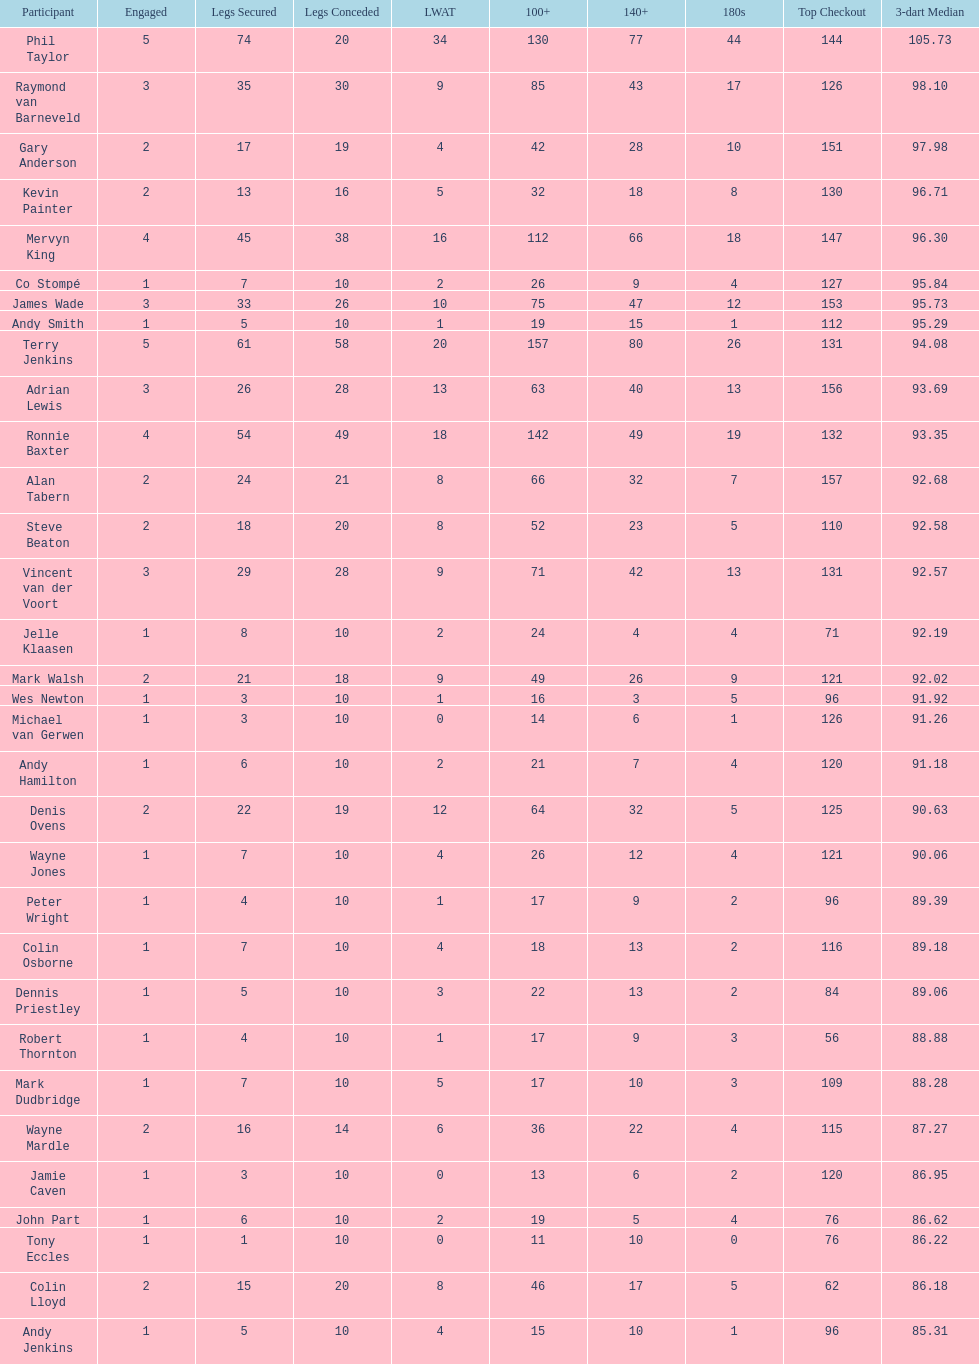How many players in the 2009 world matchplay won at least 30 legs? 6. 